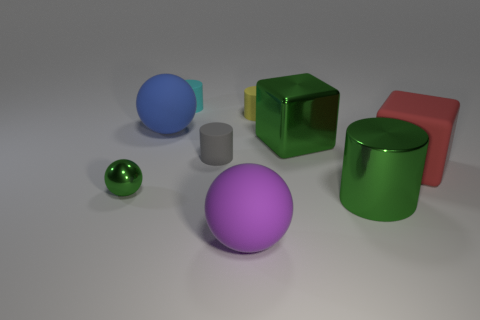The metallic block that is the same size as the rubber cube is what color? The metallic block that shares the same size with the rubber cube displays a gleaming green hue, a color that's often associated with nature and vitality. 